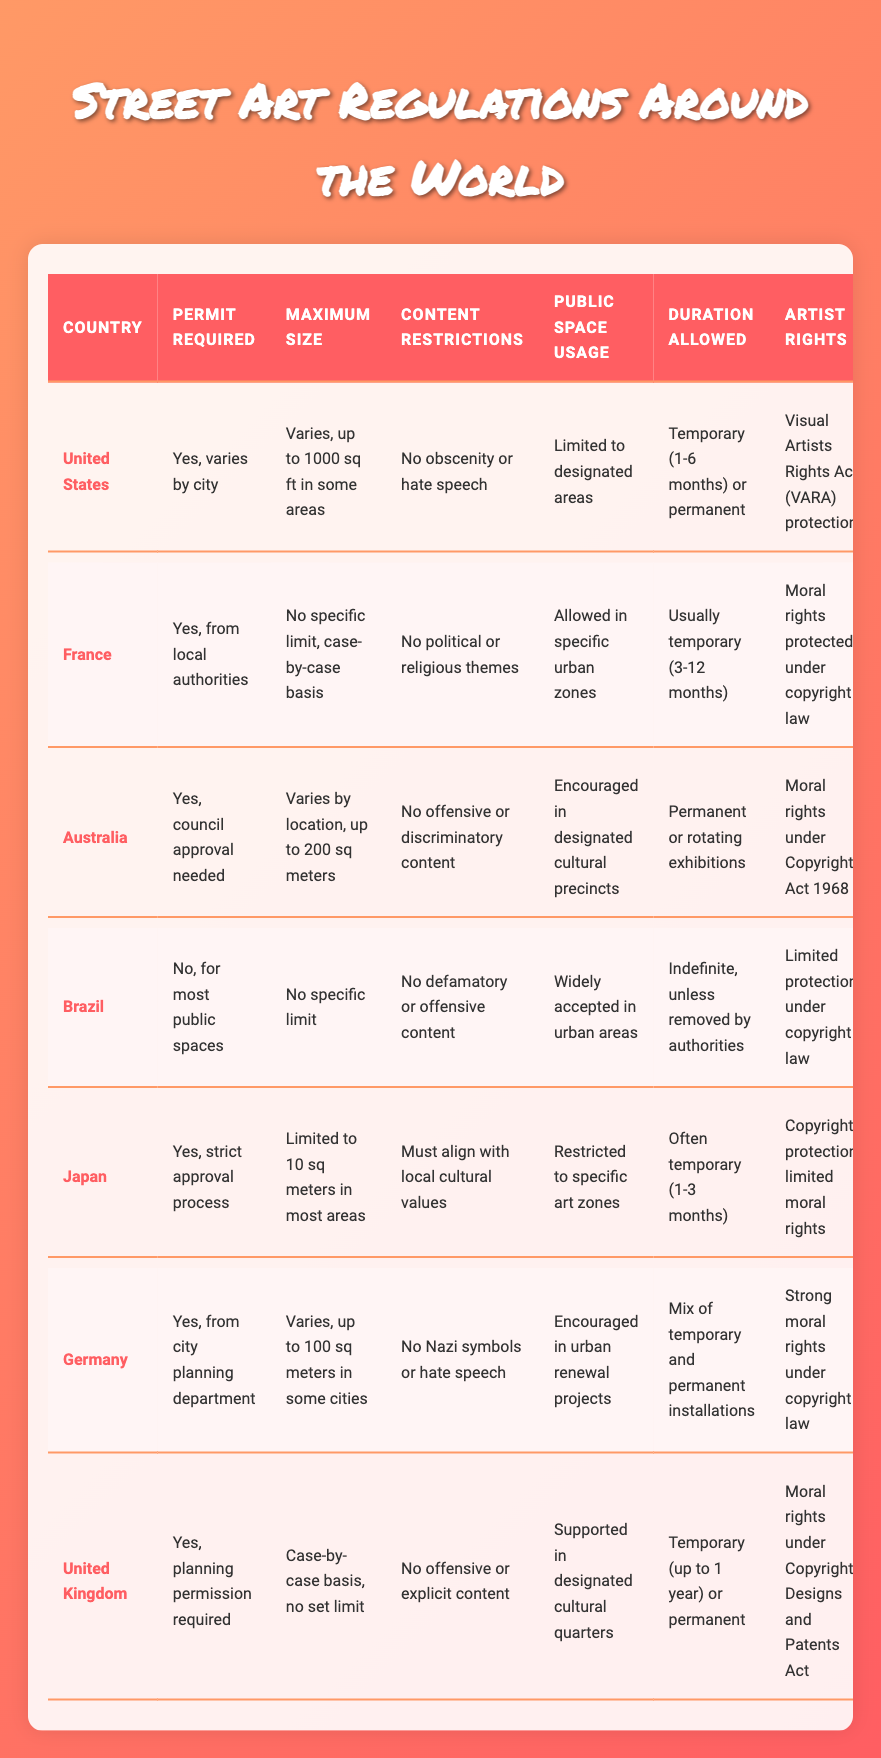What is the maximum size limit for street art in Australia? The maximum size limit for street art in Australia is "Varies by location, up to 200 sq meters." This information is directly retrieved from the table under the "Maximum Size" column for the Australia entry.
Answer: up to 200 sq meters Does Japan require a permit for public art? Yes, Japan requires a strict approval process for a permit. This is stated in the "Permit Required" column for Japan in the table.
Answer: Yes Which countries have a maximum size limit specified for public art? The countries that have a maximum size limit specified are the United States (up to 1000 sq ft), Australia (up to 200 sq meters), and Germany (up to 100 sq meters in some cities). This information can be combined from the "Maximum Size" column across the relevant countries.
Answer: United States, Australia, Germany How long is public art typically allowed to remain in the United Kingdom? In the United Kingdom, public art is allowed to be temporary (up to 1 year) or permanent. This information comes from the "Duration Allowed" column specific to the United Kingdom.
Answer: Temporary (up to 1 year) or permanent Is it true that Brazil does not require a permit for most public spaces? Yes, it is true that Brazil does not require a permit for most public spaces, as according to the "Permit Required" column in the Brazil entry.
Answer: Yes What are the content restrictions for public art in France compared to Australia? In France, the content restrictions are "No political or religious themes," while in Australia, they prohibit "offensive or discriminatory content." To compare, we look at the "Content Restrictions" column for both countries.
Answer: France: No political or religious themes; Australia: No offensive or discriminatory content What is the range of duration allowed for public art in the United States? The duration allowed for public art in the United States can either be temporary (1-6 months) or permanent, as specified in the "Duration Allowed" column for the United States.
Answer: Temporary (1-6 months) or permanent Which country has the strongest moral rights protection for artists? Germany has the strongest moral rights protection for artists, as indicated by "Strong moral rights under copyright law" in the "Artist Rights" column for Germany.
Answer: Germany 